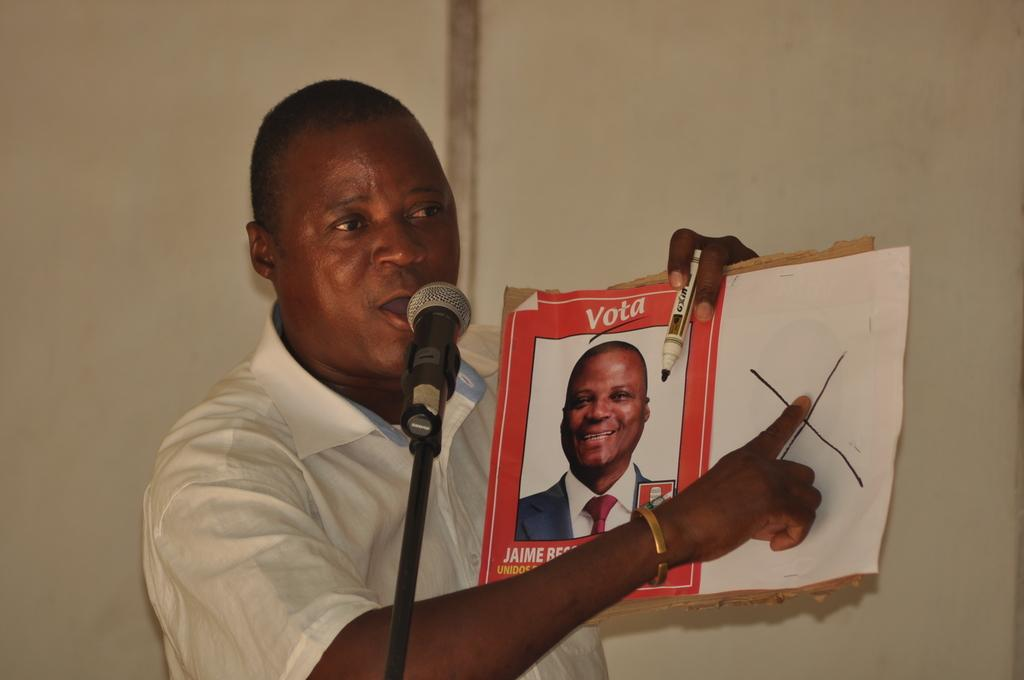Who is the main subject in the image? There is a man in the image. What is the man holding in his hands? The man is holding a sketch and a poster. What object is in front of the man? There is a microphone (mike) in front of the man. What can be seen in the background of the image? There is a wall in the background of the image. What type of beef is the man preparing in the image? There is no beef present in the image. What tools might the carpenter be using in the image? There is no carpenter present in the image, so it's not possible to determine what tools they might be using. 